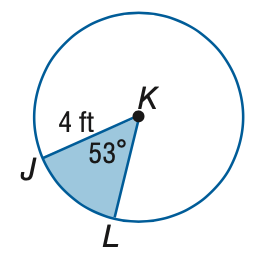Question: Find the area of the shaded sector. Round to the nearest tenth.
Choices:
A. 7.4
B. 21.4
C. 42.9
D. 50.3
Answer with the letter. Answer: A 